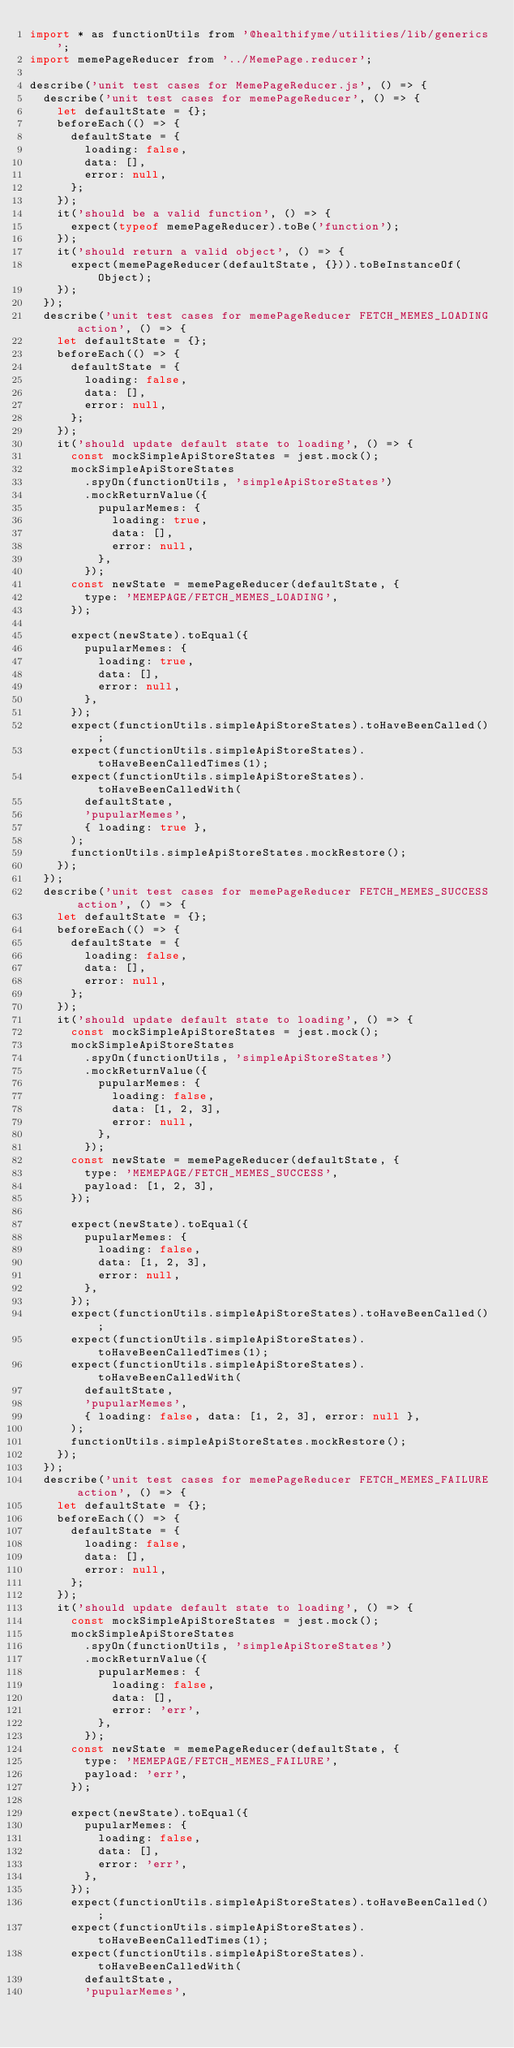<code> <loc_0><loc_0><loc_500><loc_500><_JavaScript_>import * as functionUtils from '@healthifyme/utilities/lib/generics';
import memePageReducer from '../MemePage.reducer';

describe('unit test cases for MemePageReducer.js', () => {
  describe('unit test cases for memePageReducer', () => {
    let defaultState = {};
    beforeEach(() => {
      defaultState = {
        loading: false,
        data: [],
        error: null,
      };
    });
    it('should be a valid function', () => {
      expect(typeof memePageReducer).toBe('function');
    });
    it('should return a valid object', () => {
      expect(memePageReducer(defaultState, {})).toBeInstanceOf(Object);
    });
  });
  describe('unit test cases for memePageReducer FETCH_MEMES_LOADING action', () => {
    let defaultState = {};
    beforeEach(() => {
      defaultState = {
        loading: false,
        data: [],
        error: null,
      };
    });
    it('should update default state to loading', () => {
      const mockSimpleApiStoreStates = jest.mock();
      mockSimpleApiStoreStates
        .spyOn(functionUtils, 'simpleApiStoreStates')
        .mockReturnValue({
          pupularMemes: {
            loading: true,
            data: [],
            error: null,
          },
        });
      const newState = memePageReducer(defaultState, {
        type: 'MEMEPAGE/FETCH_MEMES_LOADING',
      });

      expect(newState).toEqual({
        pupularMemes: {
          loading: true,
          data: [],
          error: null,
        },
      });
      expect(functionUtils.simpleApiStoreStates).toHaveBeenCalled();
      expect(functionUtils.simpleApiStoreStates).toHaveBeenCalledTimes(1);
      expect(functionUtils.simpleApiStoreStates).toHaveBeenCalledWith(
        defaultState,
        'pupularMemes',
        { loading: true },
      );
      functionUtils.simpleApiStoreStates.mockRestore();
    });
  });
  describe('unit test cases for memePageReducer FETCH_MEMES_SUCCESS action', () => {
    let defaultState = {};
    beforeEach(() => {
      defaultState = {
        loading: false,
        data: [],
        error: null,
      };
    });
    it('should update default state to loading', () => {
      const mockSimpleApiStoreStates = jest.mock();
      mockSimpleApiStoreStates
        .spyOn(functionUtils, 'simpleApiStoreStates')
        .mockReturnValue({
          pupularMemes: {
            loading: false,
            data: [1, 2, 3],
            error: null,
          },
        });
      const newState = memePageReducer(defaultState, {
        type: 'MEMEPAGE/FETCH_MEMES_SUCCESS',
        payload: [1, 2, 3],
      });

      expect(newState).toEqual({
        pupularMemes: {
          loading: false,
          data: [1, 2, 3],
          error: null,
        },
      });
      expect(functionUtils.simpleApiStoreStates).toHaveBeenCalled();
      expect(functionUtils.simpleApiStoreStates).toHaveBeenCalledTimes(1);
      expect(functionUtils.simpleApiStoreStates).toHaveBeenCalledWith(
        defaultState,
        'pupularMemes',
        { loading: false, data: [1, 2, 3], error: null },
      );
      functionUtils.simpleApiStoreStates.mockRestore();
    });
  });
  describe('unit test cases for memePageReducer FETCH_MEMES_FAILURE action', () => {
    let defaultState = {};
    beforeEach(() => {
      defaultState = {
        loading: false,
        data: [],
        error: null,
      };
    });
    it('should update default state to loading', () => {
      const mockSimpleApiStoreStates = jest.mock();
      mockSimpleApiStoreStates
        .spyOn(functionUtils, 'simpleApiStoreStates')
        .mockReturnValue({
          pupularMemes: {
            loading: false,
            data: [],
            error: 'err',
          },
        });
      const newState = memePageReducer(defaultState, {
        type: 'MEMEPAGE/FETCH_MEMES_FAILURE',
        payload: 'err',
      });

      expect(newState).toEqual({
        pupularMemes: {
          loading: false,
          data: [],
          error: 'err',
        },
      });
      expect(functionUtils.simpleApiStoreStates).toHaveBeenCalled();
      expect(functionUtils.simpleApiStoreStates).toHaveBeenCalledTimes(1);
      expect(functionUtils.simpleApiStoreStates).toHaveBeenCalledWith(
        defaultState,
        'pupularMemes',</code> 